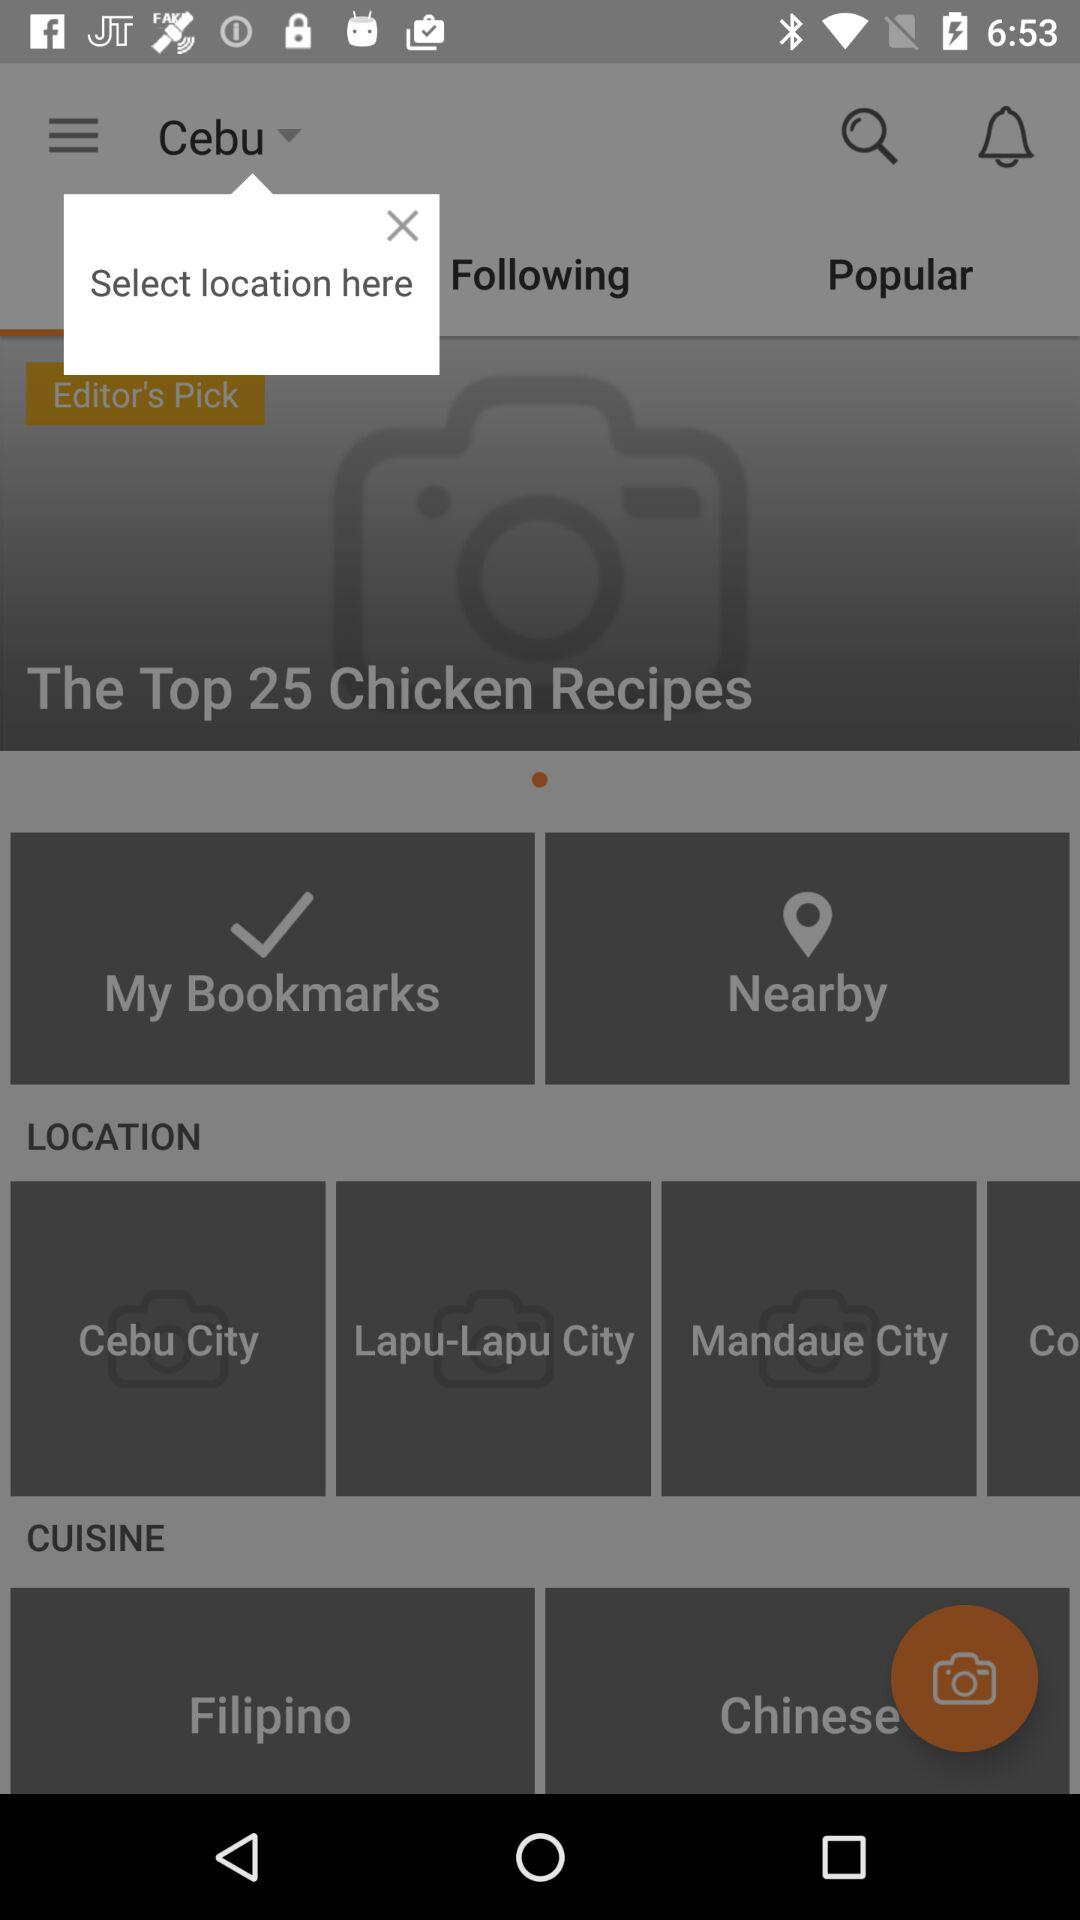What are the different available categories of cuisine? The different available categories are "Filipino" and "Chinese". 